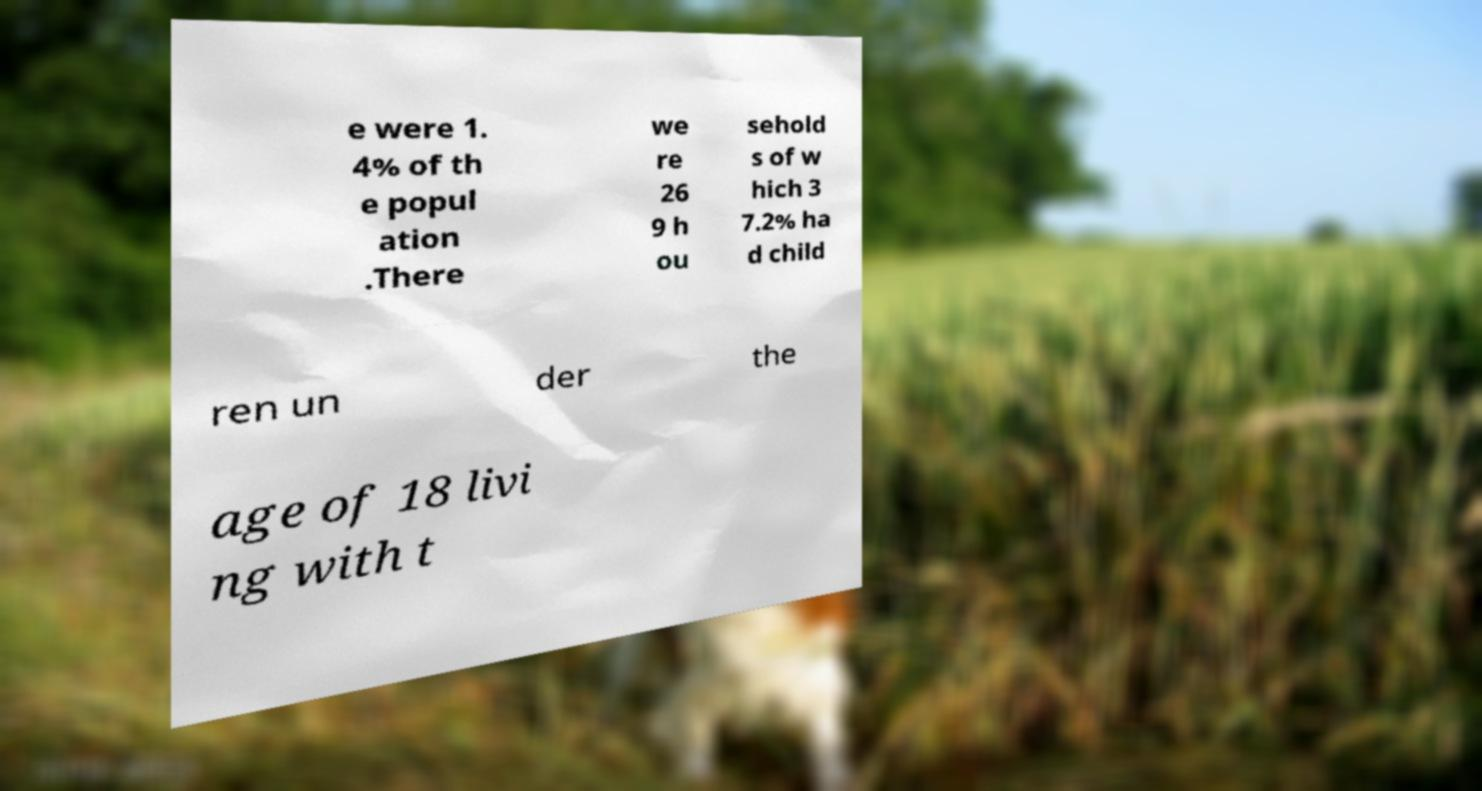Please identify and transcribe the text found in this image. e were 1. 4% of th e popul ation .There we re 26 9 h ou sehold s of w hich 3 7.2% ha d child ren un der the age of 18 livi ng with t 